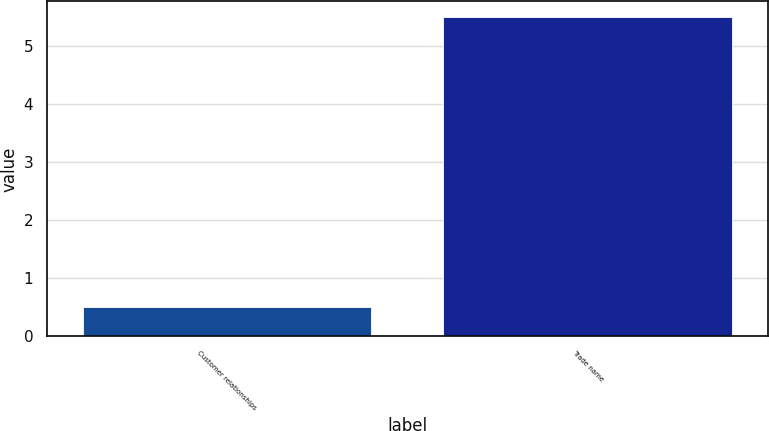Convert chart. <chart><loc_0><loc_0><loc_500><loc_500><bar_chart><fcel>Customer relationships<fcel>Trade name<nl><fcel>0.5<fcel>5.5<nl></chart> 